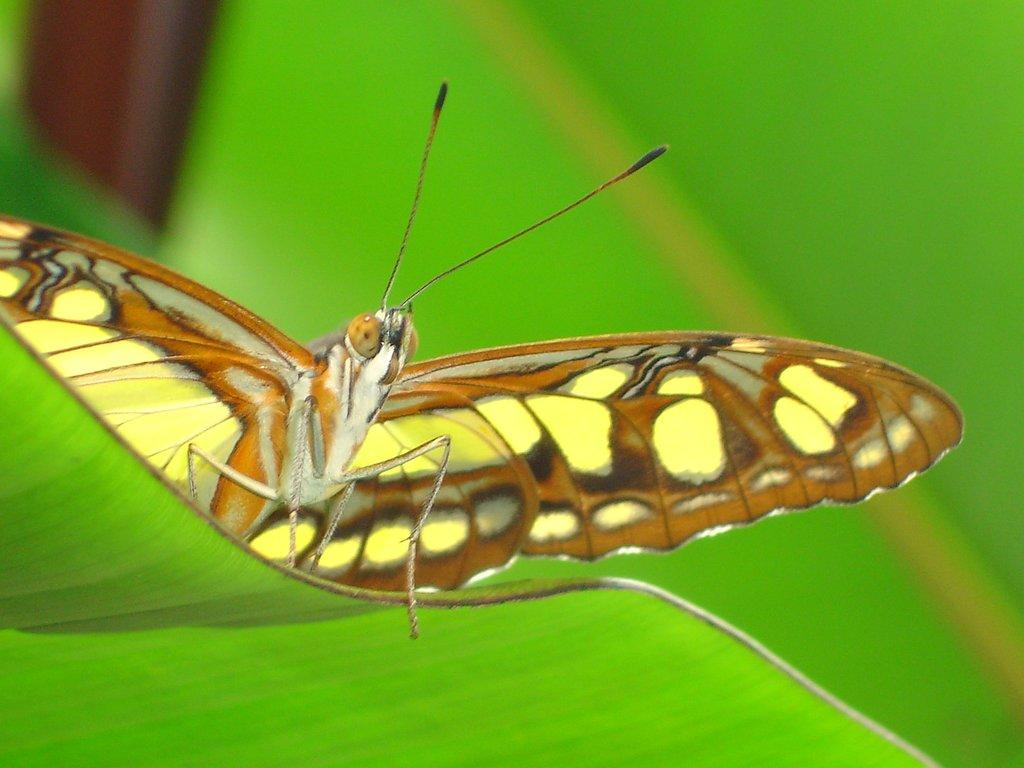What is the main subject of the image? There is a butterfly in the image. Where is the butterfly located? The butterfly is on a leaf. What type of kite is the butterfly flying with in the image? There is no kite present in the image; the butterfly is on a leaf. 